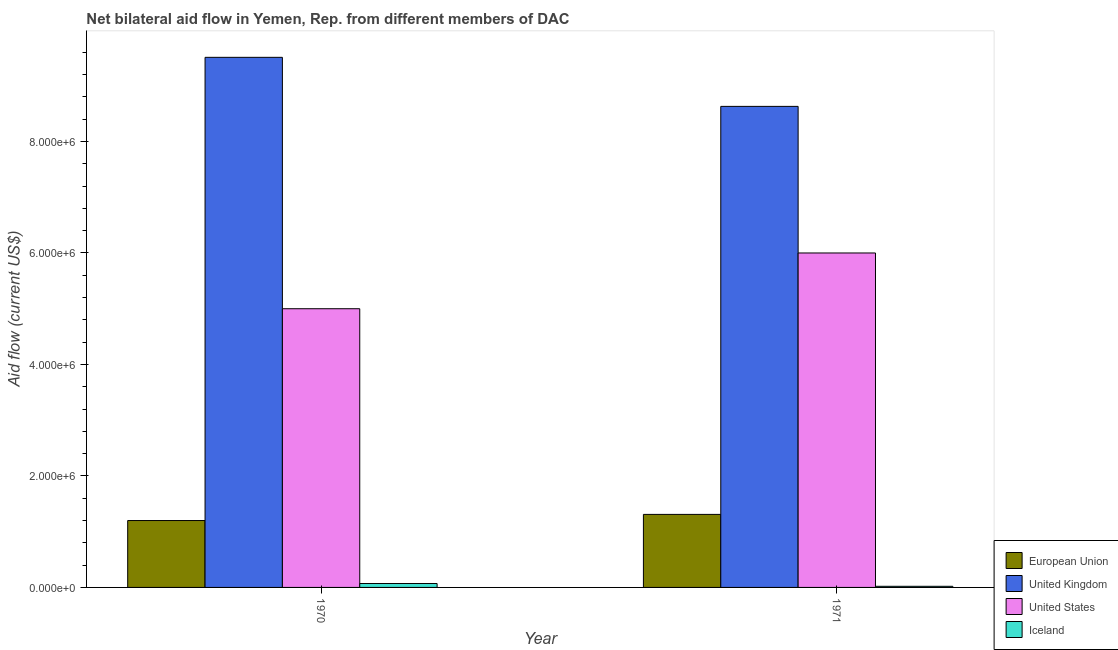How many different coloured bars are there?
Offer a terse response. 4. How many bars are there on the 1st tick from the left?
Provide a succinct answer. 4. How many bars are there on the 1st tick from the right?
Offer a terse response. 4. What is the amount of aid given by eu in 1971?
Your answer should be compact. 1.31e+06. Across all years, what is the maximum amount of aid given by iceland?
Make the answer very short. 7.00e+04. Across all years, what is the minimum amount of aid given by us?
Your response must be concise. 5.00e+06. In which year was the amount of aid given by us minimum?
Keep it short and to the point. 1970. What is the total amount of aid given by us in the graph?
Ensure brevity in your answer.  1.10e+07. What is the difference between the amount of aid given by uk in 1970 and that in 1971?
Offer a very short reply. 8.80e+05. What is the difference between the amount of aid given by uk in 1971 and the amount of aid given by eu in 1970?
Make the answer very short. -8.80e+05. What is the average amount of aid given by eu per year?
Ensure brevity in your answer.  1.26e+06. In how many years, is the amount of aid given by eu greater than 5200000 US$?
Ensure brevity in your answer.  0. What is the ratio of the amount of aid given by eu in 1970 to that in 1971?
Your answer should be compact. 0.92. Is the amount of aid given by eu in 1970 less than that in 1971?
Offer a very short reply. Yes. In how many years, is the amount of aid given by iceland greater than the average amount of aid given by iceland taken over all years?
Make the answer very short. 1. Is it the case that in every year, the sum of the amount of aid given by eu and amount of aid given by us is greater than the sum of amount of aid given by iceland and amount of aid given by uk?
Your response must be concise. Yes. Are all the bars in the graph horizontal?
Provide a succinct answer. No. What is the difference between two consecutive major ticks on the Y-axis?
Provide a short and direct response. 2.00e+06. Does the graph contain any zero values?
Your answer should be very brief. No. What is the title of the graph?
Your answer should be compact. Net bilateral aid flow in Yemen, Rep. from different members of DAC. What is the label or title of the X-axis?
Your answer should be very brief. Year. What is the Aid flow (current US$) in European Union in 1970?
Your answer should be compact. 1.20e+06. What is the Aid flow (current US$) in United Kingdom in 1970?
Ensure brevity in your answer.  9.51e+06. What is the Aid flow (current US$) of United States in 1970?
Provide a short and direct response. 5.00e+06. What is the Aid flow (current US$) in European Union in 1971?
Provide a short and direct response. 1.31e+06. What is the Aid flow (current US$) of United Kingdom in 1971?
Your answer should be compact. 8.63e+06. What is the Aid flow (current US$) of United States in 1971?
Give a very brief answer. 6.00e+06. Across all years, what is the maximum Aid flow (current US$) of European Union?
Keep it short and to the point. 1.31e+06. Across all years, what is the maximum Aid flow (current US$) in United Kingdom?
Provide a succinct answer. 9.51e+06. Across all years, what is the maximum Aid flow (current US$) in Iceland?
Give a very brief answer. 7.00e+04. Across all years, what is the minimum Aid flow (current US$) of European Union?
Keep it short and to the point. 1.20e+06. Across all years, what is the minimum Aid flow (current US$) in United Kingdom?
Your answer should be compact. 8.63e+06. What is the total Aid flow (current US$) in European Union in the graph?
Make the answer very short. 2.51e+06. What is the total Aid flow (current US$) in United Kingdom in the graph?
Make the answer very short. 1.81e+07. What is the total Aid flow (current US$) of United States in the graph?
Your answer should be very brief. 1.10e+07. What is the difference between the Aid flow (current US$) of United Kingdom in 1970 and that in 1971?
Make the answer very short. 8.80e+05. What is the difference between the Aid flow (current US$) of United States in 1970 and that in 1971?
Your response must be concise. -1.00e+06. What is the difference between the Aid flow (current US$) of European Union in 1970 and the Aid flow (current US$) of United Kingdom in 1971?
Offer a terse response. -7.43e+06. What is the difference between the Aid flow (current US$) of European Union in 1970 and the Aid flow (current US$) of United States in 1971?
Keep it short and to the point. -4.80e+06. What is the difference between the Aid flow (current US$) of European Union in 1970 and the Aid flow (current US$) of Iceland in 1971?
Provide a succinct answer. 1.18e+06. What is the difference between the Aid flow (current US$) of United Kingdom in 1970 and the Aid flow (current US$) of United States in 1971?
Make the answer very short. 3.51e+06. What is the difference between the Aid flow (current US$) of United Kingdom in 1970 and the Aid flow (current US$) of Iceland in 1971?
Your answer should be very brief. 9.49e+06. What is the difference between the Aid flow (current US$) of United States in 1970 and the Aid flow (current US$) of Iceland in 1971?
Keep it short and to the point. 4.98e+06. What is the average Aid flow (current US$) of European Union per year?
Ensure brevity in your answer.  1.26e+06. What is the average Aid flow (current US$) of United Kingdom per year?
Provide a succinct answer. 9.07e+06. What is the average Aid flow (current US$) of United States per year?
Make the answer very short. 5.50e+06. What is the average Aid flow (current US$) of Iceland per year?
Offer a very short reply. 4.50e+04. In the year 1970, what is the difference between the Aid flow (current US$) of European Union and Aid flow (current US$) of United Kingdom?
Offer a very short reply. -8.31e+06. In the year 1970, what is the difference between the Aid flow (current US$) in European Union and Aid flow (current US$) in United States?
Ensure brevity in your answer.  -3.80e+06. In the year 1970, what is the difference between the Aid flow (current US$) of European Union and Aid flow (current US$) of Iceland?
Your answer should be very brief. 1.13e+06. In the year 1970, what is the difference between the Aid flow (current US$) in United Kingdom and Aid flow (current US$) in United States?
Provide a short and direct response. 4.51e+06. In the year 1970, what is the difference between the Aid flow (current US$) of United Kingdom and Aid flow (current US$) of Iceland?
Ensure brevity in your answer.  9.44e+06. In the year 1970, what is the difference between the Aid flow (current US$) of United States and Aid flow (current US$) of Iceland?
Keep it short and to the point. 4.93e+06. In the year 1971, what is the difference between the Aid flow (current US$) of European Union and Aid flow (current US$) of United Kingdom?
Offer a very short reply. -7.32e+06. In the year 1971, what is the difference between the Aid flow (current US$) of European Union and Aid flow (current US$) of United States?
Your answer should be compact. -4.69e+06. In the year 1971, what is the difference between the Aid flow (current US$) in European Union and Aid flow (current US$) in Iceland?
Your answer should be compact. 1.29e+06. In the year 1971, what is the difference between the Aid flow (current US$) in United Kingdom and Aid flow (current US$) in United States?
Your answer should be compact. 2.63e+06. In the year 1971, what is the difference between the Aid flow (current US$) in United Kingdom and Aid flow (current US$) in Iceland?
Ensure brevity in your answer.  8.61e+06. In the year 1971, what is the difference between the Aid flow (current US$) of United States and Aid flow (current US$) of Iceland?
Offer a very short reply. 5.98e+06. What is the ratio of the Aid flow (current US$) of European Union in 1970 to that in 1971?
Make the answer very short. 0.92. What is the ratio of the Aid flow (current US$) of United Kingdom in 1970 to that in 1971?
Provide a succinct answer. 1.1. What is the ratio of the Aid flow (current US$) of United States in 1970 to that in 1971?
Give a very brief answer. 0.83. What is the ratio of the Aid flow (current US$) of Iceland in 1970 to that in 1971?
Ensure brevity in your answer.  3.5. What is the difference between the highest and the second highest Aid flow (current US$) of United Kingdom?
Your answer should be compact. 8.80e+05. What is the difference between the highest and the second highest Aid flow (current US$) in United States?
Give a very brief answer. 1.00e+06. What is the difference between the highest and the lowest Aid flow (current US$) of United Kingdom?
Ensure brevity in your answer.  8.80e+05. 